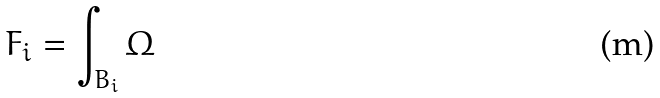<formula> <loc_0><loc_0><loc_500><loc_500>F _ { i } = \int _ { B _ { i } } \Omega</formula> 